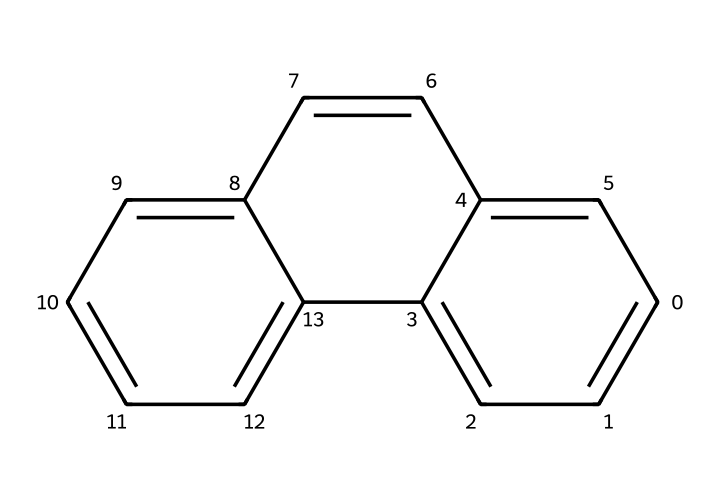What is the molecular formula of this antioxidant? To determine the molecular formula, you need to count the number of each type of atom present in the structure. The structure appears to be made up of carbon (C) and hydrogen (H) atoms. Upon analyzing it, there are 15 carbon atoms and 12 hydrogen atoms.
Answer: C15H12 How many rings are present in the chemical structure? The structure reveals multiple interconnected cylic formations. By tracing the bonds visually, I can identify a total of 3 rings within the chemical structure.
Answer: 3 What type of compounds does this structure belong to? Given the presence of multiple aromatic rings and its general structure, this compound classifies as a polycyclic aromatic hydrocarbon (PAH).
Answer: polycyclic aromatic hydrocarbon What is the anticipated antioxidant activity of this compound? Many compounds in the aromatic category, especially those with conjugated systems, exhibit strong antioxidant properties due to their ability to donate electrons and scavenge free radicals. This particular antioxidant is expected to have notable scavenging activity.
Answer: strong Identify the type of bonding present in the aromatic rings. The bonding in aromatic rings is characterized by resonance. Each carbon atom in the ring is connected by alternating single and double bonds, creating a stable aromatic system due to delocalized electrons. It is classified as covalent bonding.
Answer: covalent What might be the relevance of this compound as a space resource? Given its antioxidant properties, this compound could potentially be beneficial in protecting biological systems from oxidative stress in space habitats, making it a valuable resource for long-duration space missions.
Answer: protective resource 